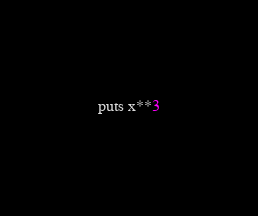<code> <loc_0><loc_0><loc_500><loc_500><_Ruby_>puts x**3
</code> 